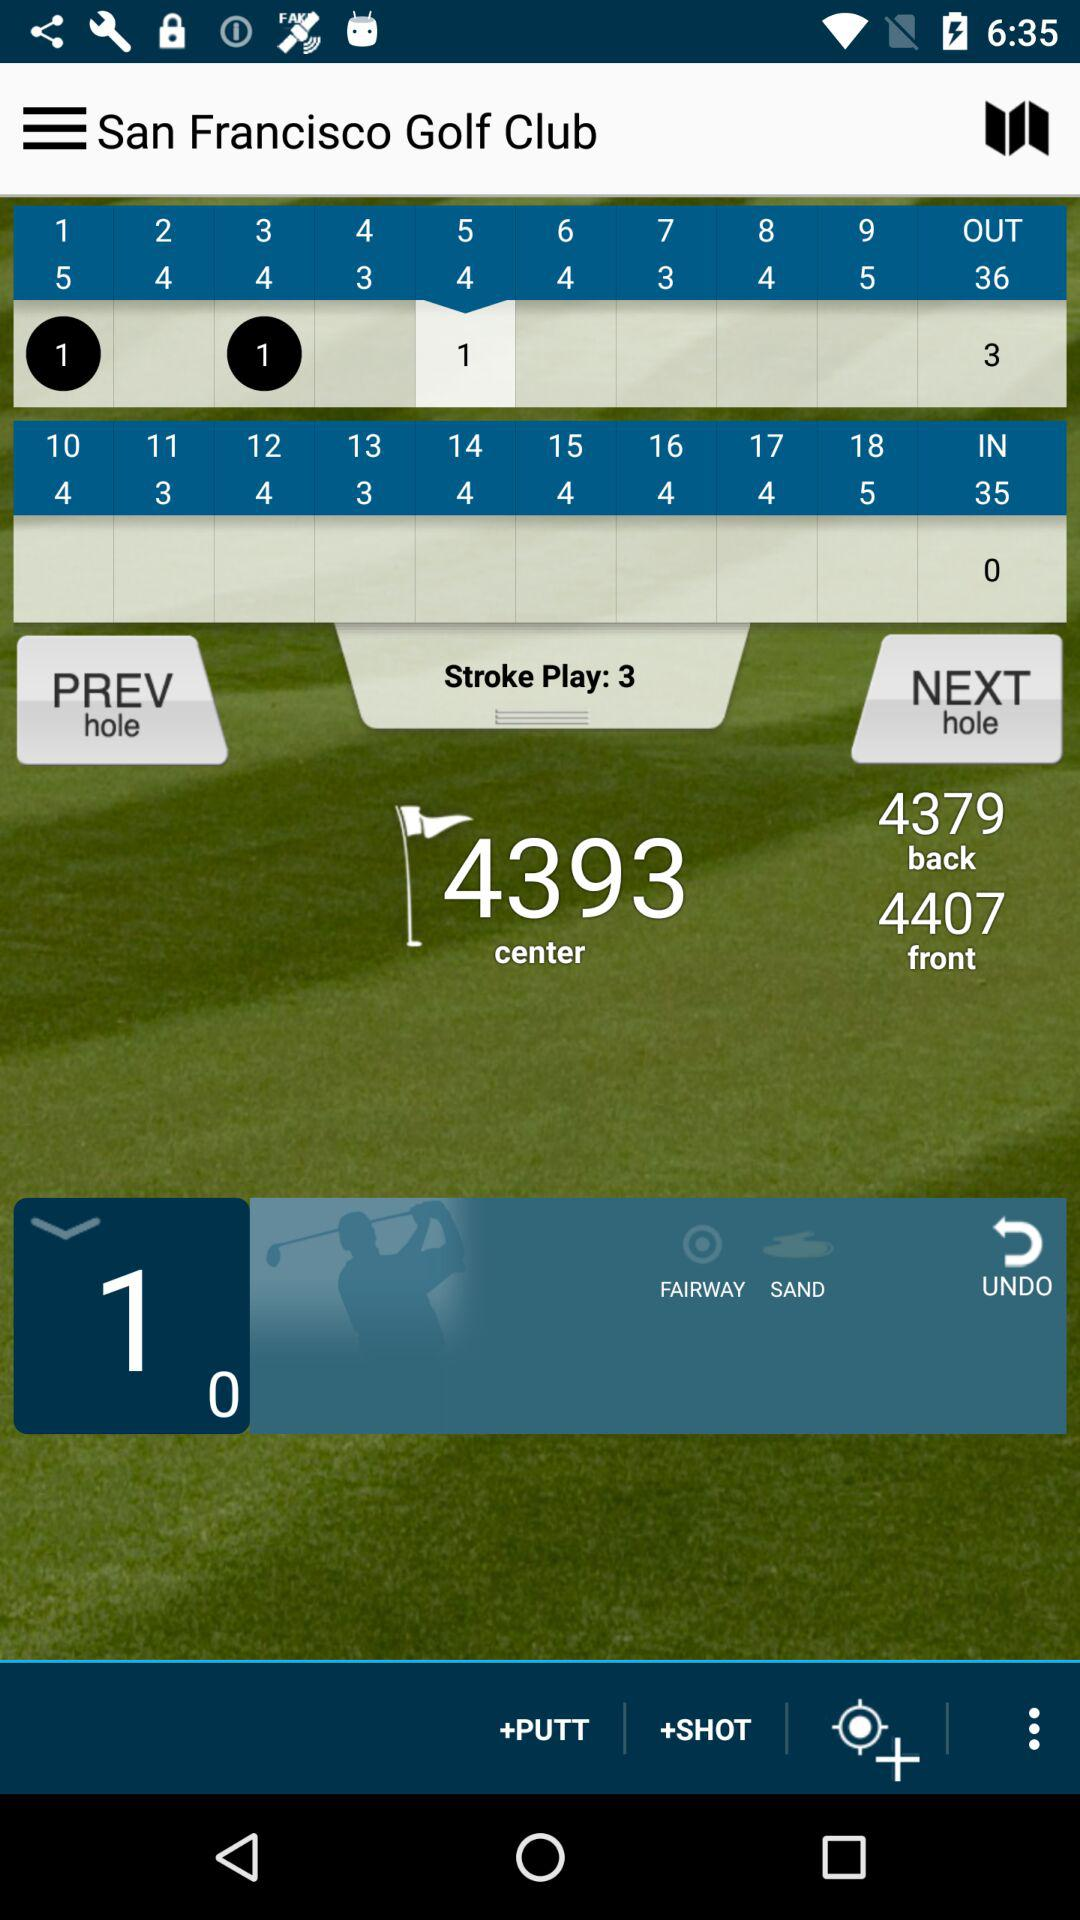What is the stroke play? The stroke play is 3. 